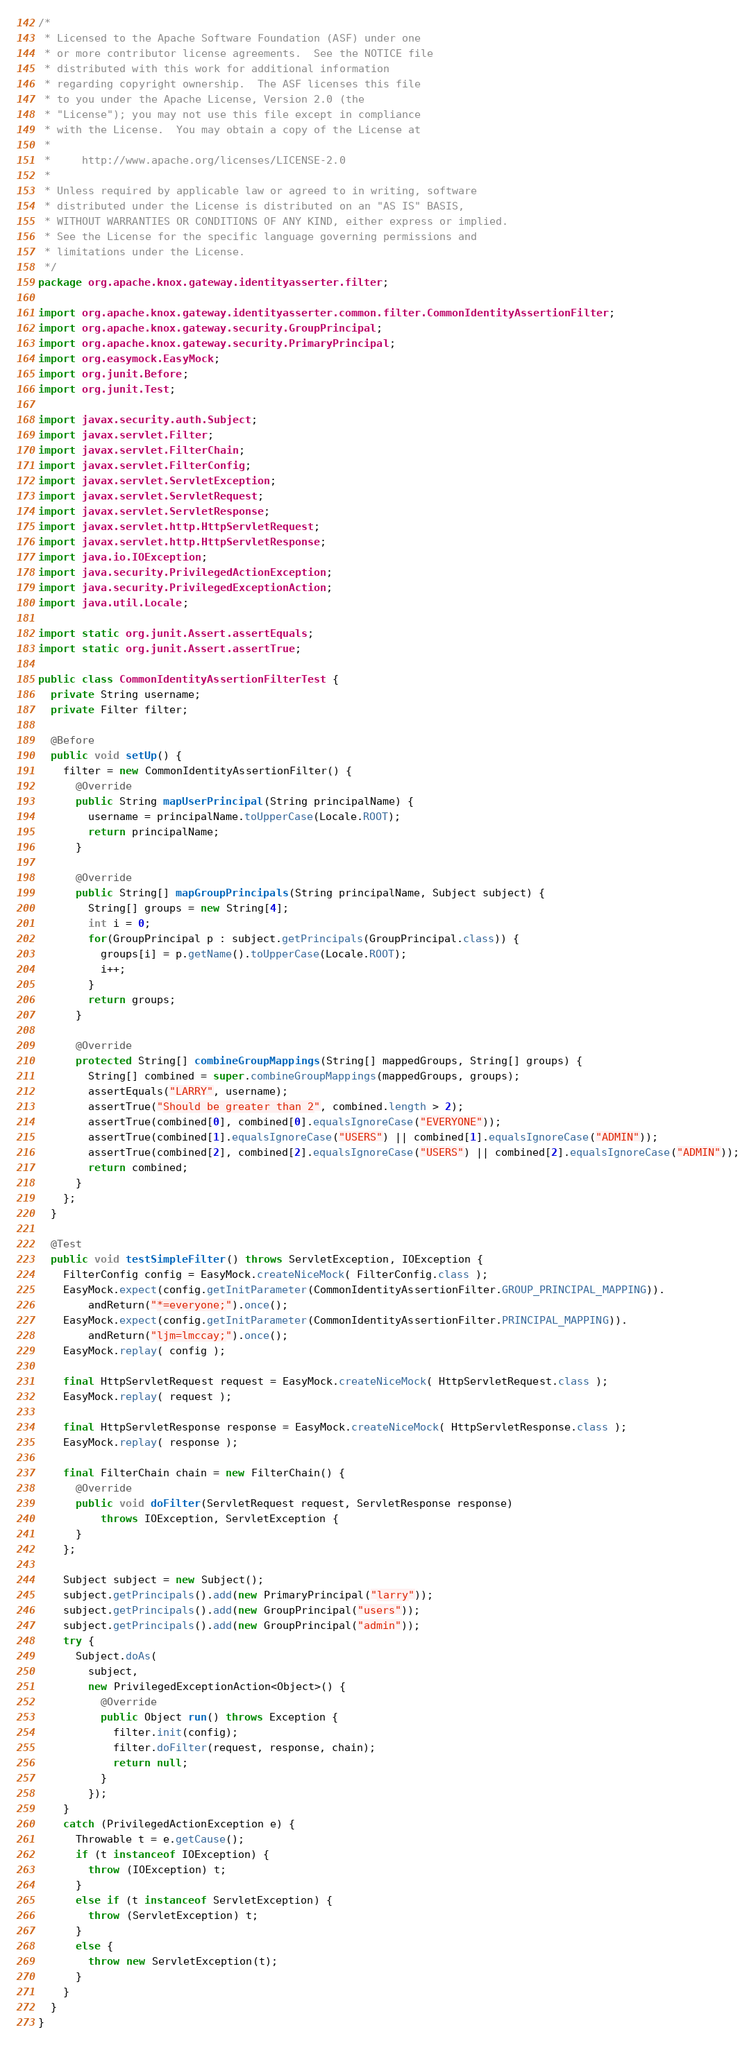<code> <loc_0><loc_0><loc_500><loc_500><_Java_>/*
 * Licensed to the Apache Software Foundation (ASF) under one
 * or more contributor license agreements.  See the NOTICE file
 * distributed with this work for additional information
 * regarding copyright ownership.  The ASF licenses this file
 * to you under the Apache License, Version 2.0 (the
 * "License"); you may not use this file except in compliance
 * with the License.  You may obtain a copy of the License at
 *
 *     http://www.apache.org/licenses/LICENSE-2.0
 *
 * Unless required by applicable law or agreed to in writing, software
 * distributed under the License is distributed on an "AS IS" BASIS,
 * WITHOUT WARRANTIES OR CONDITIONS OF ANY KIND, either express or implied.
 * See the License for the specific language governing permissions and
 * limitations under the License.
 */
package org.apache.knox.gateway.identityasserter.filter;

import org.apache.knox.gateway.identityasserter.common.filter.CommonIdentityAssertionFilter;
import org.apache.knox.gateway.security.GroupPrincipal;
import org.apache.knox.gateway.security.PrimaryPrincipal;
import org.easymock.EasyMock;
import org.junit.Before;
import org.junit.Test;

import javax.security.auth.Subject;
import javax.servlet.Filter;
import javax.servlet.FilterChain;
import javax.servlet.FilterConfig;
import javax.servlet.ServletException;
import javax.servlet.ServletRequest;
import javax.servlet.ServletResponse;
import javax.servlet.http.HttpServletRequest;
import javax.servlet.http.HttpServletResponse;
import java.io.IOException;
import java.security.PrivilegedActionException;
import java.security.PrivilegedExceptionAction;
import java.util.Locale;

import static org.junit.Assert.assertEquals;
import static org.junit.Assert.assertTrue;

public class CommonIdentityAssertionFilterTest {
  private String username;
  private Filter filter;

  @Before
  public void setUp() {
    filter = new CommonIdentityAssertionFilter() {
      @Override
      public String mapUserPrincipal(String principalName) {
        username = principalName.toUpperCase(Locale.ROOT);
        return principalName;
      }

      @Override
      public String[] mapGroupPrincipals(String principalName, Subject subject) {
        String[] groups = new String[4];
        int i = 0;
        for(GroupPrincipal p : subject.getPrincipals(GroupPrincipal.class)) {
          groups[i] = p.getName().toUpperCase(Locale.ROOT);
          i++;
        }
        return groups;
      }

      @Override
      protected String[] combineGroupMappings(String[] mappedGroups, String[] groups) {
        String[] combined = super.combineGroupMappings(mappedGroups, groups);
        assertEquals("LARRY", username);
        assertTrue("Should be greater than 2", combined.length > 2);
        assertTrue(combined[0], combined[0].equalsIgnoreCase("EVERYONE"));
        assertTrue(combined[1].equalsIgnoreCase("USERS") || combined[1].equalsIgnoreCase("ADMIN"));
        assertTrue(combined[2], combined[2].equalsIgnoreCase("USERS") || combined[2].equalsIgnoreCase("ADMIN"));
        return combined;
      }
    };
  }

  @Test
  public void testSimpleFilter() throws ServletException, IOException {
    FilterConfig config = EasyMock.createNiceMock( FilterConfig.class );
    EasyMock.expect(config.getInitParameter(CommonIdentityAssertionFilter.GROUP_PRINCIPAL_MAPPING)).
        andReturn("*=everyone;").once();
    EasyMock.expect(config.getInitParameter(CommonIdentityAssertionFilter.PRINCIPAL_MAPPING)).
        andReturn("ljm=lmccay;").once();
    EasyMock.replay( config );

    final HttpServletRequest request = EasyMock.createNiceMock( HttpServletRequest.class );
    EasyMock.replay( request );

    final HttpServletResponse response = EasyMock.createNiceMock( HttpServletResponse.class );
    EasyMock.replay( response );

    final FilterChain chain = new FilterChain() {
      @Override
      public void doFilter(ServletRequest request, ServletResponse response)
          throws IOException, ServletException {
      }
    };

    Subject subject = new Subject();
    subject.getPrincipals().add(new PrimaryPrincipal("larry"));
    subject.getPrincipals().add(new GroupPrincipal("users"));
    subject.getPrincipals().add(new GroupPrincipal("admin"));
    try {
      Subject.doAs(
        subject,
        new PrivilegedExceptionAction<Object>() {
          @Override
          public Object run() throws Exception {
            filter.init(config);
            filter.doFilter(request, response, chain);
            return null;
          }
        });
    }
    catch (PrivilegedActionException e) {
      Throwable t = e.getCause();
      if (t instanceof IOException) {
        throw (IOException) t;
      }
      else if (t instanceof ServletException) {
        throw (ServletException) t;
      }
      else {
        throw new ServletException(t);
      }
    }
  }
}
</code> 